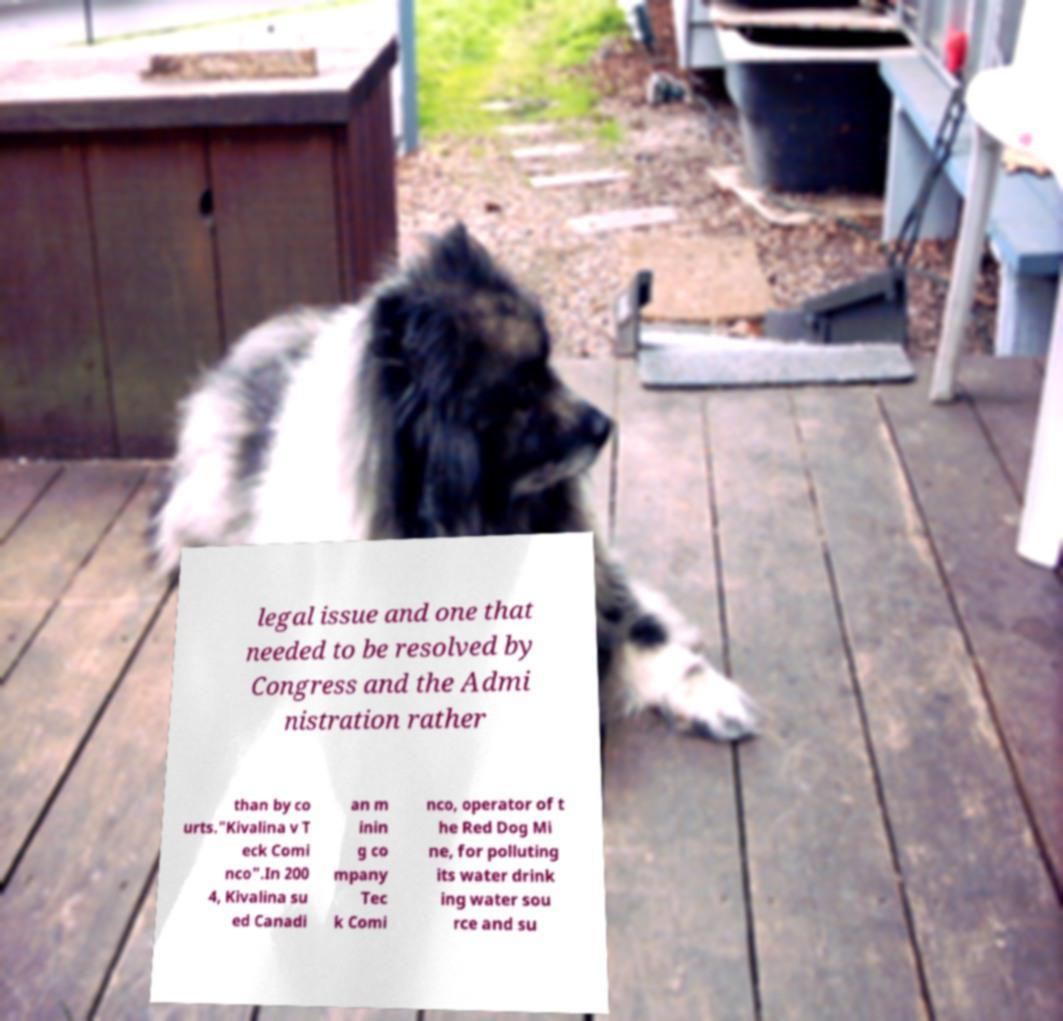Could you extract and type out the text from this image? legal issue and one that needed to be resolved by Congress and the Admi nistration rather than by co urts."Kivalina v T eck Comi nco".In 200 4, Kivalina su ed Canadi an m inin g co mpany Tec k Comi nco, operator of t he Red Dog Mi ne, for polluting its water drink ing water sou rce and su 